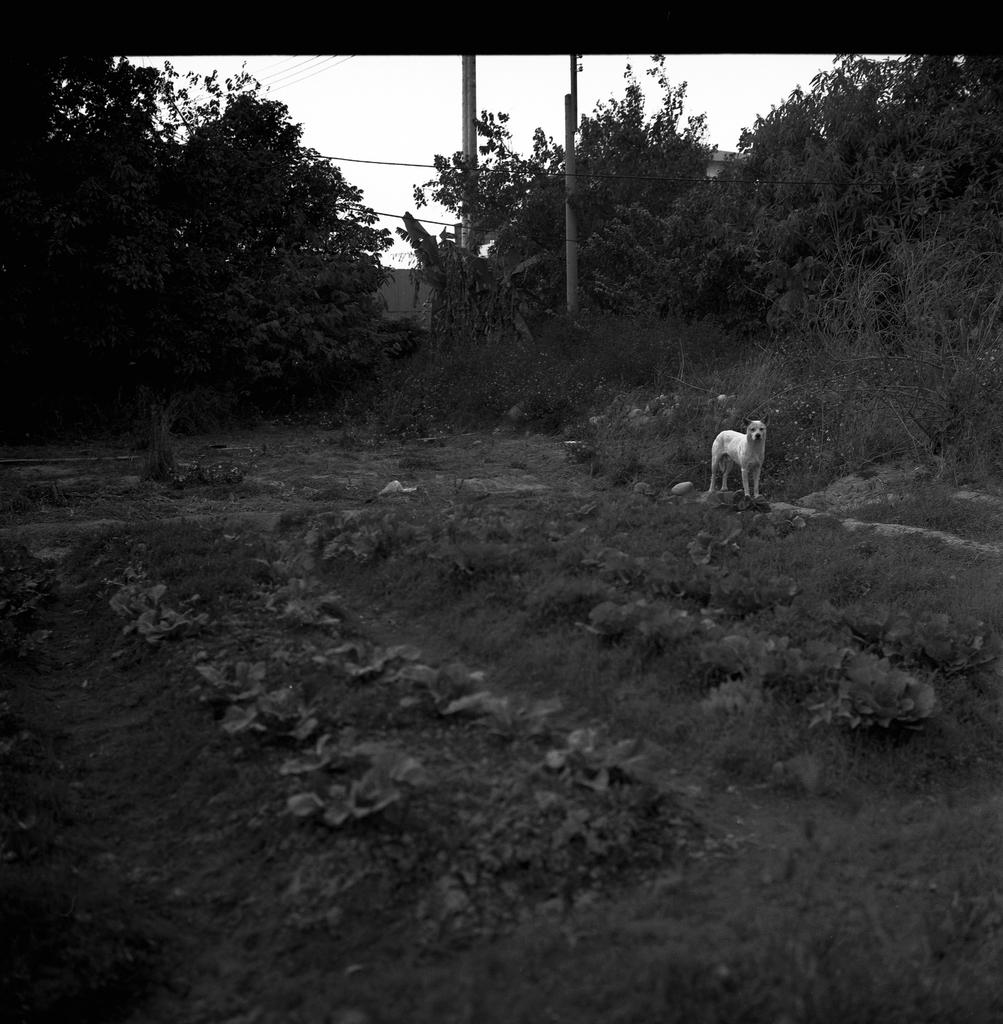What animal is present on the ground in the image? There is a dog on the ground in the image. What type of natural environment can be seen in the background of the image? There are trees in the background of the image. What architectural features are visible in the background of the image? There are poles and a building in the background of the image. What part of the natural environment is visible in the background of the image? The sky is visible in the background of the image. What type of horn can be seen on the dog in the image? There is no horn present on the dog in the image. What type of thread is being used to create the building in the image? The image does not provide information about the materials used to construct the building. 